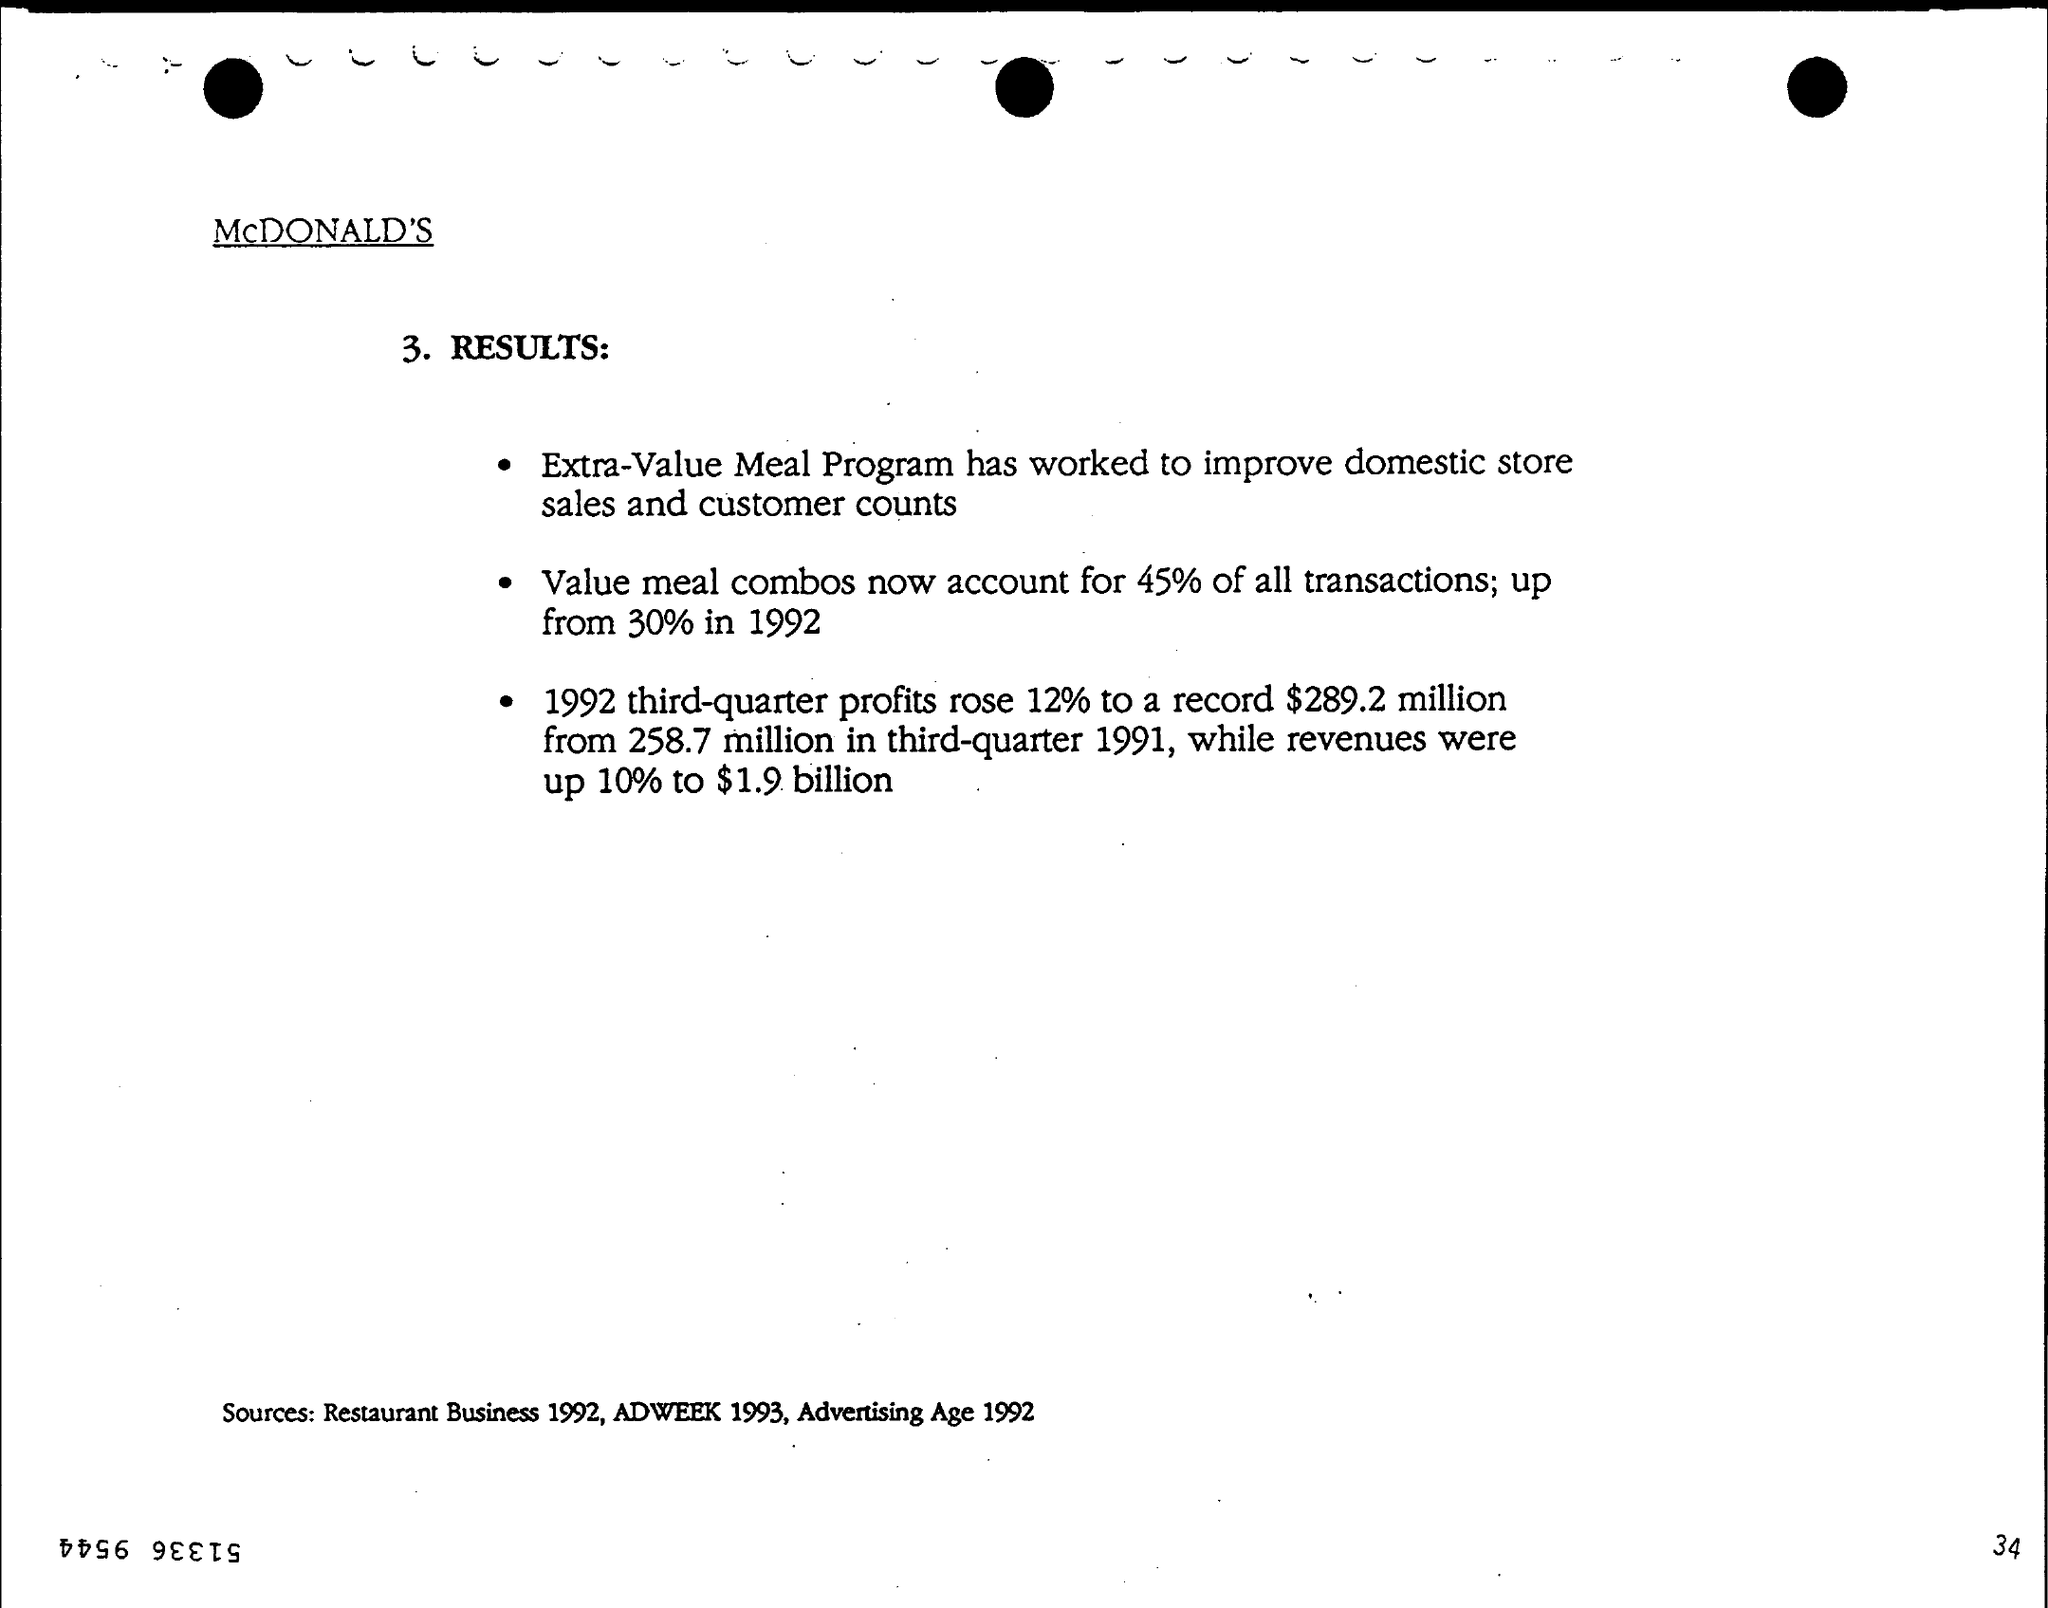What is the name of the program that has worked to improve domestic store sales and customer counts?
Offer a terse response. Extra-value  meal program. What % of profits rose in third quarter in 1992 ?
Keep it short and to the point. 12%. What is the % of value meal combos in the year 1992 ?
Your response must be concise. 30%. For what % value meal combos now account when compared to 1992 ?
Your answer should be compact. 45%. 